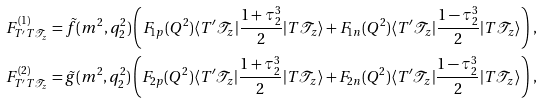Convert formula to latex. <formula><loc_0><loc_0><loc_500><loc_500>F ^ { ( 1 ) } _ { T ^ { \prime } T \mathcal { T } _ { z } } & = \tilde { f } ( m ^ { 2 } , q _ { 2 } ^ { 2 } ) \left ( F _ { 1 p } ( Q ^ { 2 } ) \langle T ^ { \prime } { \mathcal { T } } _ { z } | \frac { 1 + \tau ^ { 3 } _ { 2 } } { 2 } | T { \mathcal { T } } _ { z } \rangle + F _ { 1 n } ( Q ^ { 2 } ) \langle T ^ { \prime } { \mathcal { T } } _ { z } | \frac { 1 - \tau ^ { 3 } _ { 2 } } { 2 } | T { \mathcal { T } } _ { z } \rangle \right ) \, , \\ F ^ { ( 2 ) } _ { T ^ { \prime } T \mathcal { T } _ { z } } & = \tilde { g } ( m ^ { 2 } , q _ { 2 } ^ { 2 } ) \left ( F _ { 2 p } ( Q ^ { 2 } ) \langle T ^ { \prime } { \mathcal { T } } _ { z } | \frac { 1 + \tau ^ { 3 } _ { 2 } } { 2 } | T { \mathcal { T } } _ { z } \rangle + F _ { 2 n } ( Q ^ { 2 } ) \langle T ^ { \prime } { \mathcal { T } } _ { z } | \frac { 1 - \tau ^ { 3 } _ { 2 } } { 2 } | T { \mathcal { T } } _ { z } \rangle \right ) \, ,</formula> 